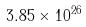<formula> <loc_0><loc_0><loc_500><loc_500>3 . 8 5 \times 1 0 ^ { 2 6 }</formula> 